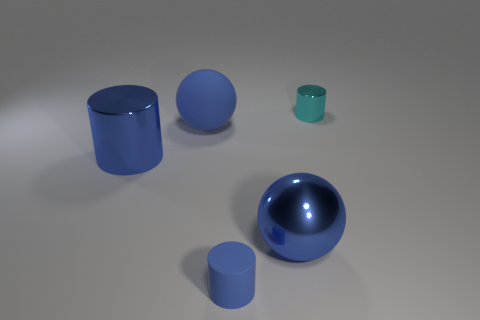How big is the cyan metallic cylinder?
Provide a succinct answer. Small. Do the shiny object right of the blue shiny ball and the shiny cylinder in front of the tiny cyan thing have the same size?
Your answer should be very brief. No. What is the size of the other matte thing that is the same shape as the cyan object?
Make the answer very short. Small. Does the rubber sphere have the same size as the rubber thing to the right of the large blue rubber thing?
Provide a succinct answer. No. There is a blue cylinder that is in front of the metal ball; are there any shiny things on the left side of it?
Ensure brevity in your answer.  Yes. The metal thing that is behind the big blue matte object has what shape?
Keep it short and to the point. Cylinder. There is a small cylinder that is the same color as the big matte thing; what material is it?
Your answer should be very brief. Rubber. The small cylinder that is behind the small thing that is in front of the small cyan cylinder is what color?
Your answer should be compact. Cyan. Do the metallic ball and the cyan metal thing have the same size?
Keep it short and to the point. No. There is another large blue thing that is the same shape as the large matte thing; what material is it?
Provide a short and direct response. Metal. 